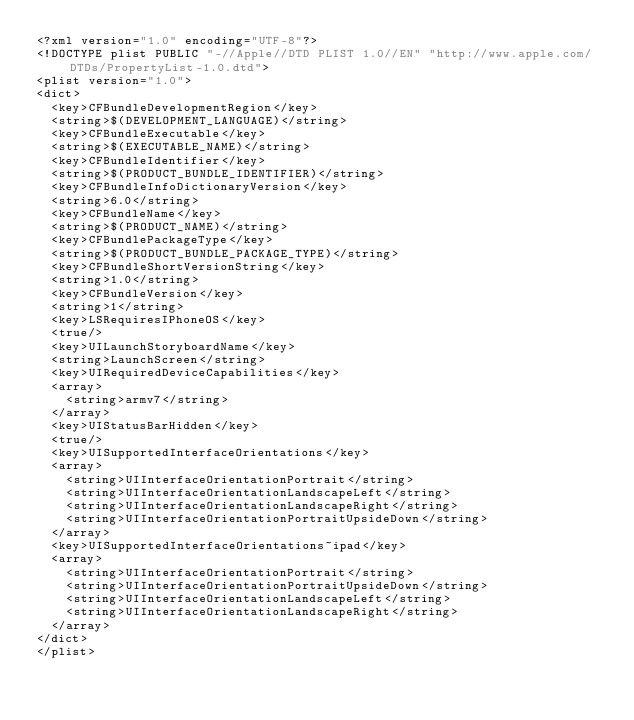Convert code to text. <code><loc_0><loc_0><loc_500><loc_500><_XML_><?xml version="1.0" encoding="UTF-8"?>
<!DOCTYPE plist PUBLIC "-//Apple//DTD PLIST 1.0//EN" "http://www.apple.com/DTDs/PropertyList-1.0.dtd">
<plist version="1.0">
<dict>
	<key>CFBundleDevelopmentRegion</key>
	<string>$(DEVELOPMENT_LANGUAGE)</string>
	<key>CFBundleExecutable</key>
	<string>$(EXECUTABLE_NAME)</string>
	<key>CFBundleIdentifier</key>
	<string>$(PRODUCT_BUNDLE_IDENTIFIER)</string>
	<key>CFBundleInfoDictionaryVersion</key>
	<string>6.0</string>
	<key>CFBundleName</key>
	<string>$(PRODUCT_NAME)</string>
	<key>CFBundlePackageType</key>
	<string>$(PRODUCT_BUNDLE_PACKAGE_TYPE)</string>
	<key>CFBundleShortVersionString</key>
	<string>1.0</string>
	<key>CFBundleVersion</key>
	<string>1</string>
	<key>LSRequiresIPhoneOS</key>
	<true/>
	<key>UILaunchStoryboardName</key>
	<string>LaunchScreen</string>
	<key>UIRequiredDeviceCapabilities</key>
	<array>
		<string>armv7</string>
	</array>
	<key>UIStatusBarHidden</key>
	<true/>
	<key>UISupportedInterfaceOrientations</key>
	<array>
		<string>UIInterfaceOrientationPortrait</string>
		<string>UIInterfaceOrientationLandscapeLeft</string>
		<string>UIInterfaceOrientationLandscapeRight</string>
		<string>UIInterfaceOrientationPortraitUpsideDown</string>
	</array>
	<key>UISupportedInterfaceOrientations~ipad</key>
	<array>
		<string>UIInterfaceOrientationPortrait</string>
		<string>UIInterfaceOrientationPortraitUpsideDown</string>
		<string>UIInterfaceOrientationLandscapeLeft</string>
		<string>UIInterfaceOrientationLandscapeRight</string>
	</array>
</dict>
</plist>
</code> 